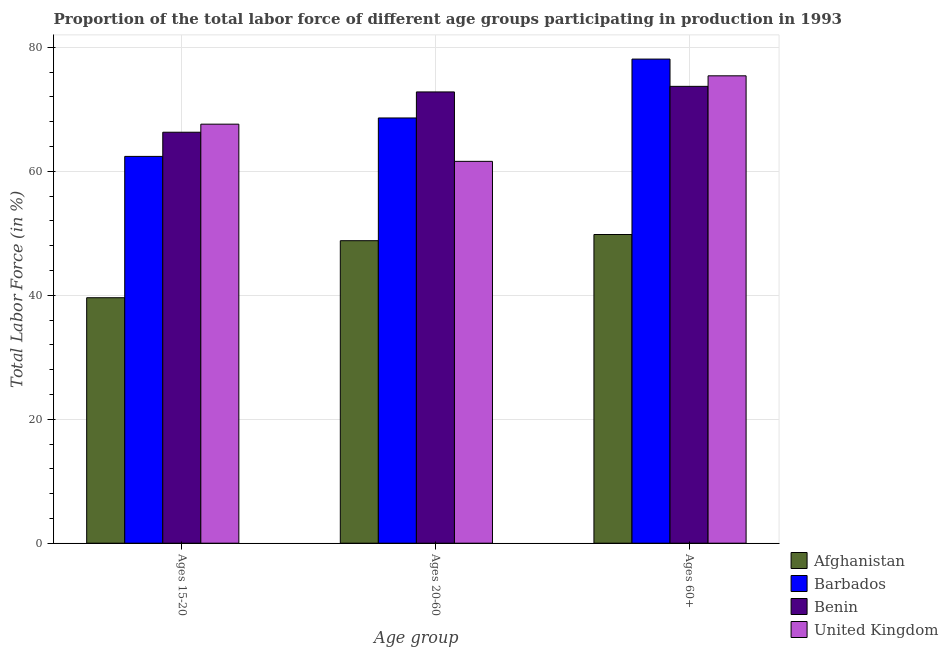How many bars are there on the 2nd tick from the right?
Provide a succinct answer. 4. What is the label of the 3rd group of bars from the left?
Ensure brevity in your answer.  Ages 60+. What is the percentage of labor force within the age group 20-60 in Afghanistan?
Keep it short and to the point. 48.8. Across all countries, what is the maximum percentage of labor force within the age group 20-60?
Provide a succinct answer. 72.8. Across all countries, what is the minimum percentage of labor force within the age group 15-20?
Provide a short and direct response. 39.6. In which country was the percentage of labor force within the age group 20-60 maximum?
Offer a very short reply. Benin. In which country was the percentage of labor force above age 60 minimum?
Your answer should be compact. Afghanistan. What is the total percentage of labor force within the age group 20-60 in the graph?
Offer a very short reply. 251.8. What is the difference between the percentage of labor force within the age group 15-20 in Barbados and that in Afghanistan?
Offer a terse response. 22.8. What is the difference between the percentage of labor force above age 60 in Barbados and the percentage of labor force within the age group 15-20 in Benin?
Your answer should be very brief. 11.8. What is the average percentage of labor force within the age group 15-20 per country?
Offer a very short reply. 58.98. What is the difference between the percentage of labor force above age 60 and percentage of labor force within the age group 20-60 in Afghanistan?
Provide a succinct answer. 1. In how many countries, is the percentage of labor force above age 60 greater than 36 %?
Provide a succinct answer. 4. What is the ratio of the percentage of labor force within the age group 20-60 in United Kingdom to that in Afghanistan?
Offer a terse response. 1.26. Is the difference between the percentage of labor force within the age group 15-20 in Benin and United Kingdom greater than the difference between the percentage of labor force within the age group 20-60 in Benin and United Kingdom?
Offer a terse response. No. What is the difference between the highest and the second highest percentage of labor force within the age group 15-20?
Your answer should be very brief. 1.3. What is the difference between the highest and the lowest percentage of labor force above age 60?
Provide a short and direct response. 28.3. In how many countries, is the percentage of labor force within the age group 20-60 greater than the average percentage of labor force within the age group 20-60 taken over all countries?
Make the answer very short. 2. Is the sum of the percentage of labor force within the age group 20-60 in United Kingdom and Barbados greater than the maximum percentage of labor force within the age group 15-20 across all countries?
Provide a succinct answer. Yes. What does the 1st bar from the right in Ages 20-60 represents?
Keep it short and to the point. United Kingdom. Is it the case that in every country, the sum of the percentage of labor force within the age group 15-20 and percentage of labor force within the age group 20-60 is greater than the percentage of labor force above age 60?
Your answer should be compact. Yes. How many bars are there?
Make the answer very short. 12. Are all the bars in the graph horizontal?
Provide a succinct answer. No. How many countries are there in the graph?
Provide a short and direct response. 4. What is the difference between two consecutive major ticks on the Y-axis?
Provide a short and direct response. 20. Are the values on the major ticks of Y-axis written in scientific E-notation?
Offer a very short reply. No. Does the graph contain any zero values?
Your answer should be compact. No. Where does the legend appear in the graph?
Offer a very short reply. Bottom right. How many legend labels are there?
Offer a very short reply. 4. What is the title of the graph?
Your answer should be very brief. Proportion of the total labor force of different age groups participating in production in 1993. What is the label or title of the X-axis?
Offer a very short reply. Age group. What is the Total Labor Force (in %) in Afghanistan in Ages 15-20?
Provide a succinct answer. 39.6. What is the Total Labor Force (in %) of Barbados in Ages 15-20?
Offer a very short reply. 62.4. What is the Total Labor Force (in %) in Benin in Ages 15-20?
Keep it short and to the point. 66.3. What is the Total Labor Force (in %) of United Kingdom in Ages 15-20?
Your response must be concise. 67.6. What is the Total Labor Force (in %) of Afghanistan in Ages 20-60?
Your response must be concise. 48.8. What is the Total Labor Force (in %) of Barbados in Ages 20-60?
Your response must be concise. 68.6. What is the Total Labor Force (in %) of Benin in Ages 20-60?
Your response must be concise. 72.8. What is the Total Labor Force (in %) of United Kingdom in Ages 20-60?
Ensure brevity in your answer.  61.6. What is the Total Labor Force (in %) of Afghanistan in Ages 60+?
Provide a short and direct response. 49.8. What is the Total Labor Force (in %) in Barbados in Ages 60+?
Provide a succinct answer. 78.1. What is the Total Labor Force (in %) in Benin in Ages 60+?
Your response must be concise. 73.7. What is the Total Labor Force (in %) of United Kingdom in Ages 60+?
Your answer should be compact. 75.4. Across all Age group, what is the maximum Total Labor Force (in %) in Afghanistan?
Provide a short and direct response. 49.8. Across all Age group, what is the maximum Total Labor Force (in %) of Barbados?
Provide a short and direct response. 78.1. Across all Age group, what is the maximum Total Labor Force (in %) of Benin?
Your answer should be compact. 73.7. Across all Age group, what is the maximum Total Labor Force (in %) of United Kingdom?
Make the answer very short. 75.4. Across all Age group, what is the minimum Total Labor Force (in %) of Afghanistan?
Keep it short and to the point. 39.6. Across all Age group, what is the minimum Total Labor Force (in %) of Barbados?
Offer a terse response. 62.4. Across all Age group, what is the minimum Total Labor Force (in %) of Benin?
Your answer should be compact. 66.3. Across all Age group, what is the minimum Total Labor Force (in %) of United Kingdom?
Give a very brief answer. 61.6. What is the total Total Labor Force (in %) of Afghanistan in the graph?
Your response must be concise. 138.2. What is the total Total Labor Force (in %) in Barbados in the graph?
Offer a terse response. 209.1. What is the total Total Labor Force (in %) of Benin in the graph?
Provide a succinct answer. 212.8. What is the total Total Labor Force (in %) in United Kingdom in the graph?
Provide a short and direct response. 204.6. What is the difference between the Total Labor Force (in %) in Afghanistan in Ages 15-20 and that in Ages 20-60?
Your answer should be compact. -9.2. What is the difference between the Total Labor Force (in %) of Barbados in Ages 15-20 and that in Ages 20-60?
Your answer should be very brief. -6.2. What is the difference between the Total Labor Force (in %) in United Kingdom in Ages 15-20 and that in Ages 20-60?
Your answer should be compact. 6. What is the difference between the Total Labor Force (in %) of Afghanistan in Ages 15-20 and that in Ages 60+?
Give a very brief answer. -10.2. What is the difference between the Total Labor Force (in %) of Barbados in Ages 15-20 and that in Ages 60+?
Your answer should be very brief. -15.7. What is the difference between the Total Labor Force (in %) in United Kingdom in Ages 15-20 and that in Ages 60+?
Make the answer very short. -7.8. What is the difference between the Total Labor Force (in %) of Afghanistan in Ages 20-60 and that in Ages 60+?
Ensure brevity in your answer.  -1. What is the difference between the Total Labor Force (in %) in Barbados in Ages 20-60 and that in Ages 60+?
Offer a very short reply. -9.5. What is the difference between the Total Labor Force (in %) of Benin in Ages 20-60 and that in Ages 60+?
Keep it short and to the point. -0.9. What is the difference between the Total Labor Force (in %) of United Kingdom in Ages 20-60 and that in Ages 60+?
Your answer should be compact. -13.8. What is the difference between the Total Labor Force (in %) of Afghanistan in Ages 15-20 and the Total Labor Force (in %) of Barbados in Ages 20-60?
Your response must be concise. -29. What is the difference between the Total Labor Force (in %) of Afghanistan in Ages 15-20 and the Total Labor Force (in %) of Benin in Ages 20-60?
Provide a succinct answer. -33.2. What is the difference between the Total Labor Force (in %) of Afghanistan in Ages 15-20 and the Total Labor Force (in %) of United Kingdom in Ages 20-60?
Your answer should be very brief. -22. What is the difference between the Total Labor Force (in %) of Barbados in Ages 15-20 and the Total Labor Force (in %) of Benin in Ages 20-60?
Offer a terse response. -10.4. What is the difference between the Total Labor Force (in %) of Barbados in Ages 15-20 and the Total Labor Force (in %) of United Kingdom in Ages 20-60?
Provide a succinct answer. 0.8. What is the difference between the Total Labor Force (in %) in Benin in Ages 15-20 and the Total Labor Force (in %) in United Kingdom in Ages 20-60?
Keep it short and to the point. 4.7. What is the difference between the Total Labor Force (in %) in Afghanistan in Ages 15-20 and the Total Labor Force (in %) in Barbados in Ages 60+?
Your answer should be very brief. -38.5. What is the difference between the Total Labor Force (in %) of Afghanistan in Ages 15-20 and the Total Labor Force (in %) of Benin in Ages 60+?
Provide a succinct answer. -34.1. What is the difference between the Total Labor Force (in %) in Afghanistan in Ages 15-20 and the Total Labor Force (in %) in United Kingdom in Ages 60+?
Offer a terse response. -35.8. What is the difference between the Total Labor Force (in %) in Barbados in Ages 15-20 and the Total Labor Force (in %) in Benin in Ages 60+?
Make the answer very short. -11.3. What is the difference between the Total Labor Force (in %) in Barbados in Ages 15-20 and the Total Labor Force (in %) in United Kingdom in Ages 60+?
Offer a very short reply. -13. What is the difference between the Total Labor Force (in %) in Afghanistan in Ages 20-60 and the Total Labor Force (in %) in Barbados in Ages 60+?
Make the answer very short. -29.3. What is the difference between the Total Labor Force (in %) in Afghanistan in Ages 20-60 and the Total Labor Force (in %) in Benin in Ages 60+?
Keep it short and to the point. -24.9. What is the difference between the Total Labor Force (in %) in Afghanistan in Ages 20-60 and the Total Labor Force (in %) in United Kingdom in Ages 60+?
Ensure brevity in your answer.  -26.6. What is the difference between the Total Labor Force (in %) in Barbados in Ages 20-60 and the Total Labor Force (in %) in Benin in Ages 60+?
Ensure brevity in your answer.  -5.1. What is the average Total Labor Force (in %) of Afghanistan per Age group?
Make the answer very short. 46.07. What is the average Total Labor Force (in %) of Barbados per Age group?
Your answer should be very brief. 69.7. What is the average Total Labor Force (in %) of Benin per Age group?
Your response must be concise. 70.93. What is the average Total Labor Force (in %) in United Kingdom per Age group?
Make the answer very short. 68.2. What is the difference between the Total Labor Force (in %) in Afghanistan and Total Labor Force (in %) in Barbados in Ages 15-20?
Your answer should be very brief. -22.8. What is the difference between the Total Labor Force (in %) of Afghanistan and Total Labor Force (in %) of Benin in Ages 15-20?
Ensure brevity in your answer.  -26.7. What is the difference between the Total Labor Force (in %) of Barbados and Total Labor Force (in %) of Benin in Ages 15-20?
Offer a very short reply. -3.9. What is the difference between the Total Labor Force (in %) in Benin and Total Labor Force (in %) in United Kingdom in Ages 15-20?
Your answer should be compact. -1.3. What is the difference between the Total Labor Force (in %) of Afghanistan and Total Labor Force (in %) of Barbados in Ages 20-60?
Provide a succinct answer. -19.8. What is the difference between the Total Labor Force (in %) of Afghanistan and Total Labor Force (in %) of Benin in Ages 20-60?
Your answer should be compact. -24. What is the difference between the Total Labor Force (in %) of Benin and Total Labor Force (in %) of United Kingdom in Ages 20-60?
Provide a succinct answer. 11.2. What is the difference between the Total Labor Force (in %) of Afghanistan and Total Labor Force (in %) of Barbados in Ages 60+?
Your answer should be compact. -28.3. What is the difference between the Total Labor Force (in %) in Afghanistan and Total Labor Force (in %) in Benin in Ages 60+?
Offer a very short reply. -23.9. What is the difference between the Total Labor Force (in %) of Afghanistan and Total Labor Force (in %) of United Kingdom in Ages 60+?
Provide a short and direct response. -25.6. What is the ratio of the Total Labor Force (in %) of Afghanistan in Ages 15-20 to that in Ages 20-60?
Ensure brevity in your answer.  0.81. What is the ratio of the Total Labor Force (in %) in Barbados in Ages 15-20 to that in Ages 20-60?
Provide a succinct answer. 0.91. What is the ratio of the Total Labor Force (in %) in Benin in Ages 15-20 to that in Ages 20-60?
Offer a terse response. 0.91. What is the ratio of the Total Labor Force (in %) of United Kingdom in Ages 15-20 to that in Ages 20-60?
Give a very brief answer. 1.1. What is the ratio of the Total Labor Force (in %) of Afghanistan in Ages 15-20 to that in Ages 60+?
Provide a short and direct response. 0.8. What is the ratio of the Total Labor Force (in %) of Barbados in Ages 15-20 to that in Ages 60+?
Make the answer very short. 0.8. What is the ratio of the Total Labor Force (in %) of Benin in Ages 15-20 to that in Ages 60+?
Your answer should be compact. 0.9. What is the ratio of the Total Labor Force (in %) of United Kingdom in Ages 15-20 to that in Ages 60+?
Your answer should be compact. 0.9. What is the ratio of the Total Labor Force (in %) in Afghanistan in Ages 20-60 to that in Ages 60+?
Ensure brevity in your answer.  0.98. What is the ratio of the Total Labor Force (in %) of Barbados in Ages 20-60 to that in Ages 60+?
Provide a short and direct response. 0.88. What is the ratio of the Total Labor Force (in %) of Benin in Ages 20-60 to that in Ages 60+?
Provide a short and direct response. 0.99. What is the ratio of the Total Labor Force (in %) in United Kingdom in Ages 20-60 to that in Ages 60+?
Your answer should be very brief. 0.82. What is the difference between the highest and the lowest Total Labor Force (in %) in Afghanistan?
Ensure brevity in your answer.  10.2. What is the difference between the highest and the lowest Total Labor Force (in %) in Barbados?
Offer a very short reply. 15.7. What is the difference between the highest and the lowest Total Labor Force (in %) in United Kingdom?
Provide a short and direct response. 13.8. 